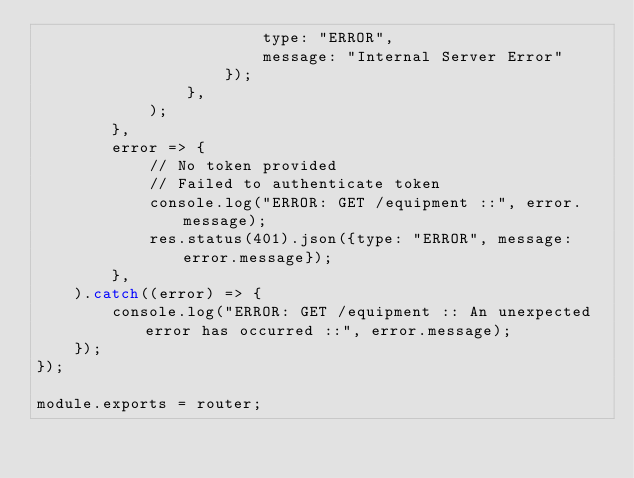<code> <loc_0><loc_0><loc_500><loc_500><_JavaScript_>                        type: "ERROR",
                        message: "Internal Server Error"
                    });
                },
            );
        },
        error => {
            // No token provided
            // Failed to authenticate token
            console.log("ERROR: GET /equipment ::", error.message);
            res.status(401).json({type: "ERROR", message: error.message});
        },
    ).catch((error) => {
        console.log("ERROR: GET /equipment :: An unexpected error has occurred ::", error.message);
    });
});

module.exports = router;
</code> 